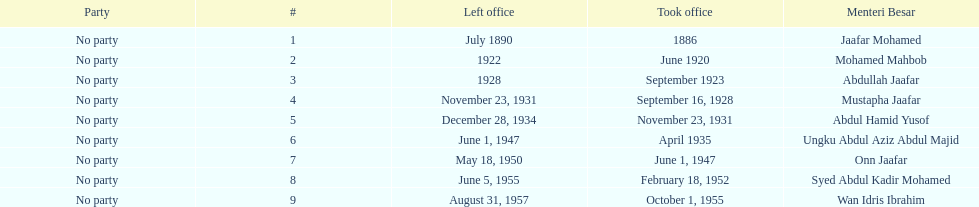Who took office after abdullah jaafar? Mustapha Jaafar. 